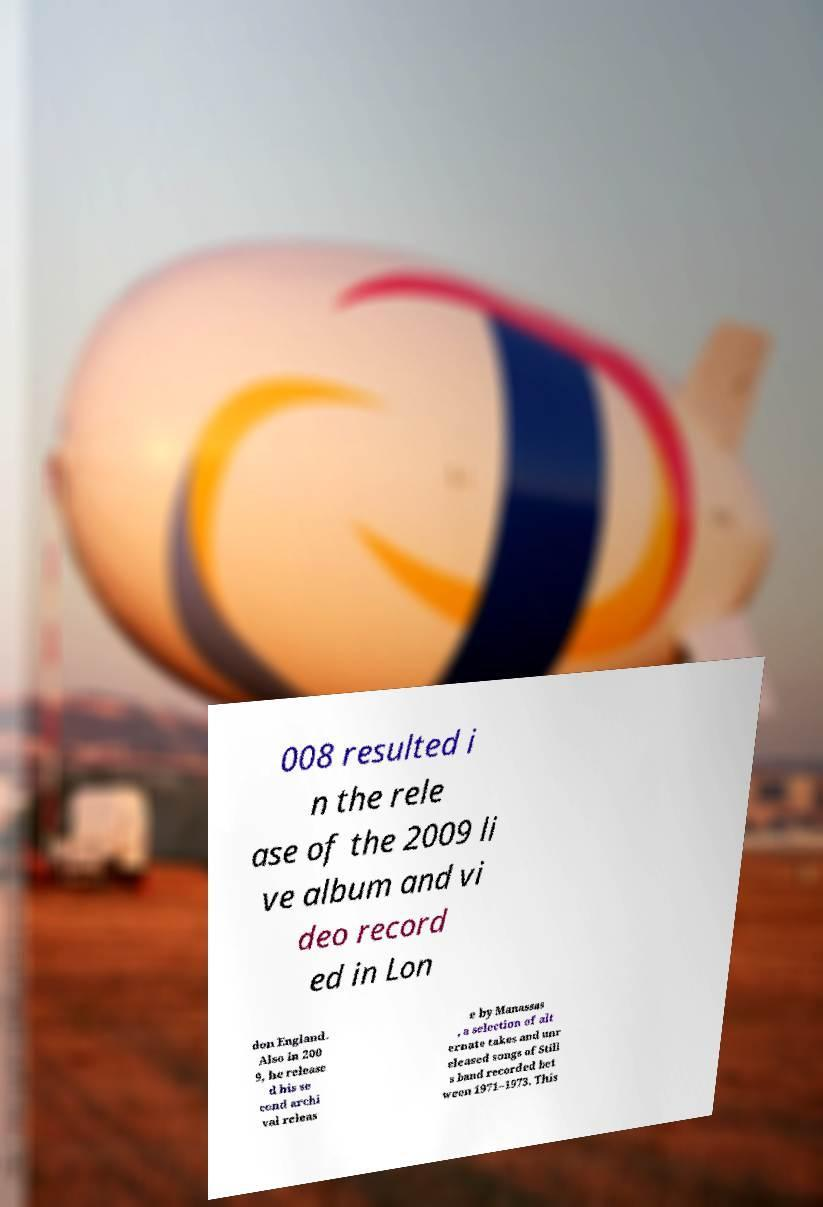What messages or text are displayed in this image? I need them in a readable, typed format. 008 resulted i n the rele ase of the 2009 li ve album and vi deo record ed in Lon don England. Also in 200 9, he release d his se cond archi val releas e by Manassas , a selection of alt ernate takes and unr eleased songs of Still s band recorded bet ween 1971–1973. This 